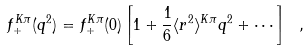Convert formula to latex. <formula><loc_0><loc_0><loc_500><loc_500>f _ { + } ^ { K \pi } ( q ^ { 2 } ) = f _ { + } ^ { K \pi } ( 0 ) \left [ 1 + \frac { 1 } { 6 } \langle r ^ { 2 } \rangle ^ { K \pi } q ^ { 2 } + \cdots \right ] \ ,</formula> 